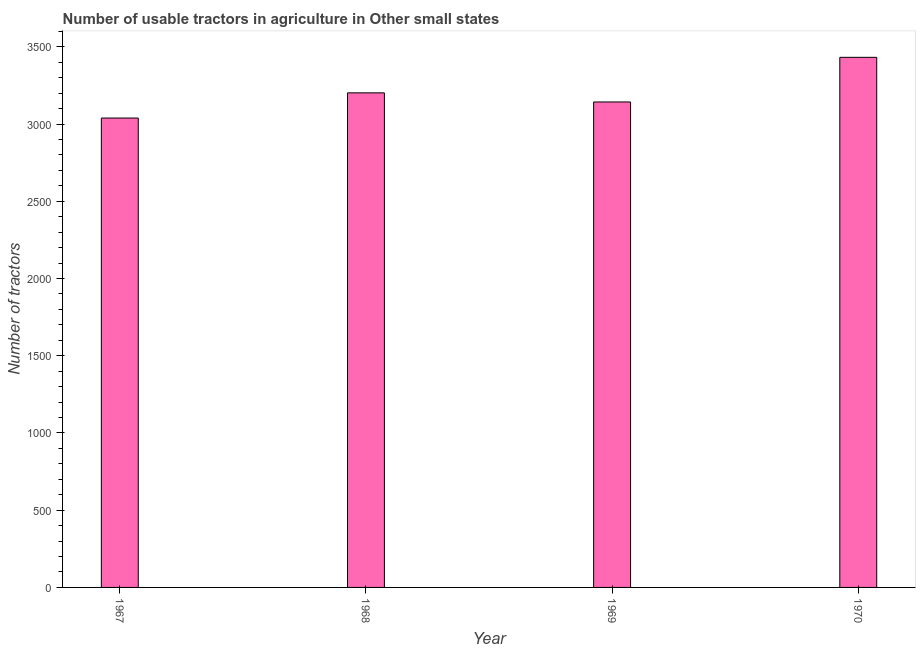What is the title of the graph?
Your response must be concise. Number of usable tractors in agriculture in Other small states. What is the label or title of the Y-axis?
Give a very brief answer. Number of tractors. What is the number of tractors in 1967?
Your answer should be compact. 3039. Across all years, what is the maximum number of tractors?
Make the answer very short. 3432. Across all years, what is the minimum number of tractors?
Your answer should be very brief. 3039. In which year was the number of tractors minimum?
Provide a succinct answer. 1967. What is the sum of the number of tractors?
Provide a short and direct response. 1.28e+04. What is the difference between the number of tractors in 1967 and 1968?
Make the answer very short. -163. What is the average number of tractors per year?
Your answer should be very brief. 3204. What is the median number of tractors?
Make the answer very short. 3172.5. In how many years, is the number of tractors greater than 3200 ?
Provide a short and direct response. 2. Do a majority of the years between 1967 and 1969 (inclusive) have number of tractors greater than 2800 ?
Offer a very short reply. Yes. What is the ratio of the number of tractors in 1967 to that in 1968?
Keep it short and to the point. 0.95. Is the number of tractors in 1967 less than that in 1969?
Give a very brief answer. Yes. Is the difference between the number of tractors in 1967 and 1968 greater than the difference between any two years?
Your response must be concise. No. What is the difference between the highest and the second highest number of tractors?
Make the answer very short. 230. What is the difference between the highest and the lowest number of tractors?
Provide a succinct answer. 393. In how many years, is the number of tractors greater than the average number of tractors taken over all years?
Give a very brief answer. 1. What is the difference between two consecutive major ticks on the Y-axis?
Offer a terse response. 500. What is the Number of tractors of 1967?
Your answer should be very brief. 3039. What is the Number of tractors of 1968?
Ensure brevity in your answer.  3202. What is the Number of tractors of 1969?
Offer a terse response. 3143. What is the Number of tractors of 1970?
Offer a terse response. 3432. What is the difference between the Number of tractors in 1967 and 1968?
Provide a short and direct response. -163. What is the difference between the Number of tractors in 1967 and 1969?
Ensure brevity in your answer.  -104. What is the difference between the Number of tractors in 1967 and 1970?
Provide a succinct answer. -393. What is the difference between the Number of tractors in 1968 and 1970?
Offer a terse response. -230. What is the difference between the Number of tractors in 1969 and 1970?
Offer a terse response. -289. What is the ratio of the Number of tractors in 1967 to that in 1968?
Provide a short and direct response. 0.95. What is the ratio of the Number of tractors in 1967 to that in 1970?
Your answer should be very brief. 0.89. What is the ratio of the Number of tractors in 1968 to that in 1969?
Provide a succinct answer. 1.02. What is the ratio of the Number of tractors in 1968 to that in 1970?
Keep it short and to the point. 0.93. What is the ratio of the Number of tractors in 1969 to that in 1970?
Your answer should be compact. 0.92. 